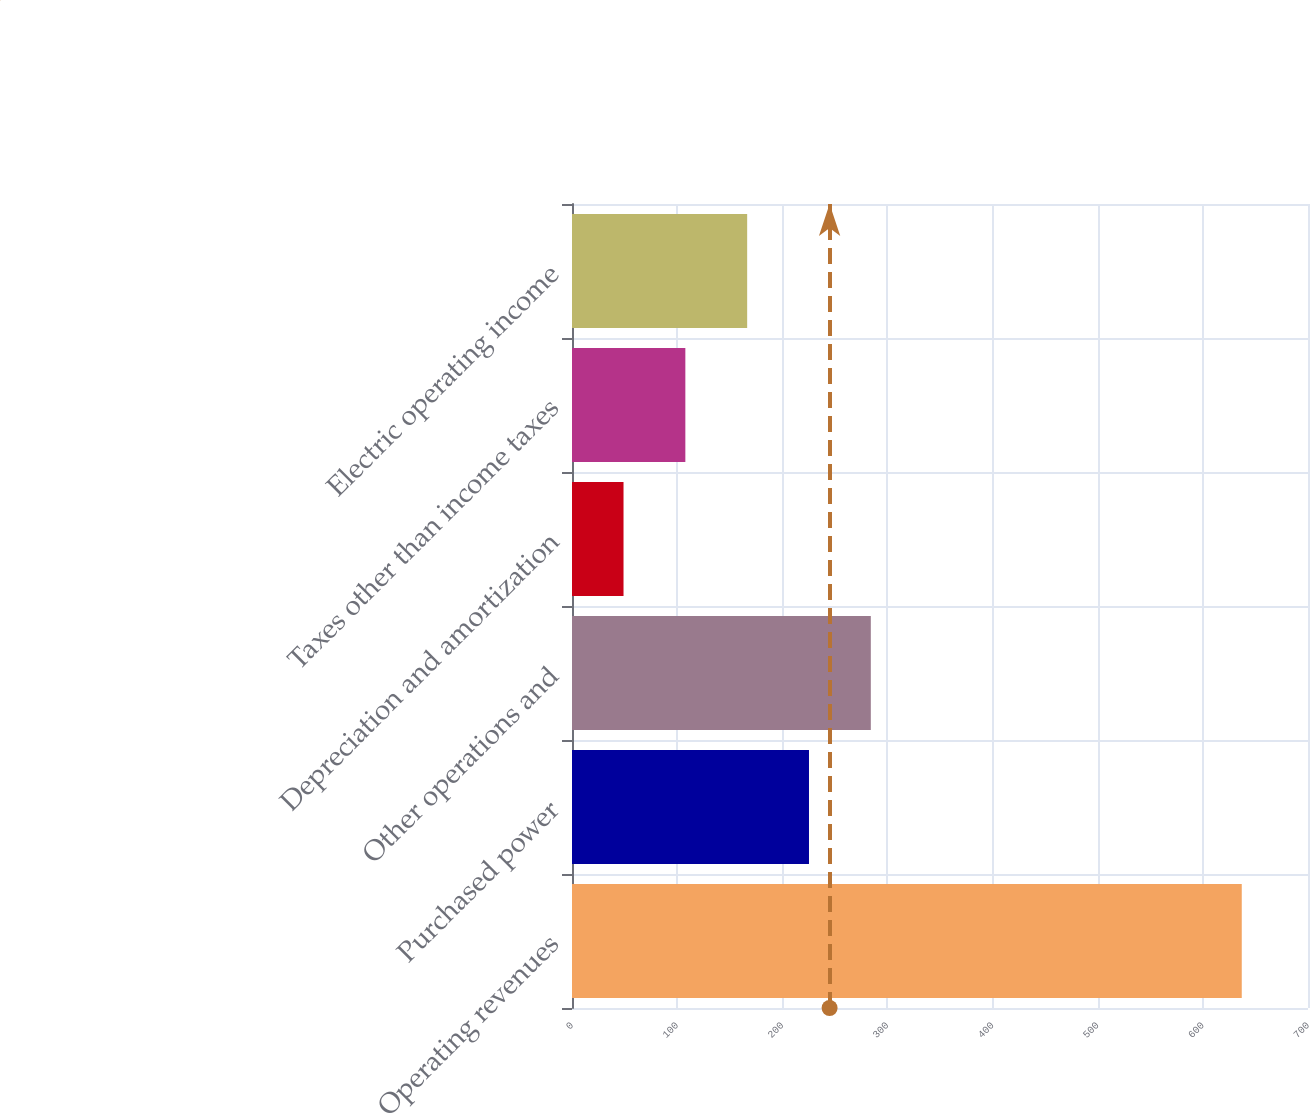<chart> <loc_0><loc_0><loc_500><loc_500><bar_chart><fcel>Operating revenues<fcel>Purchased power<fcel>Other operations and<fcel>Depreciation and amortization<fcel>Taxes other than income taxes<fcel>Electric operating income<nl><fcel>637<fcel>225.4<fcel>284.2<fcel>49<fcel>107.8<fcel>166.6<nl></chart> 